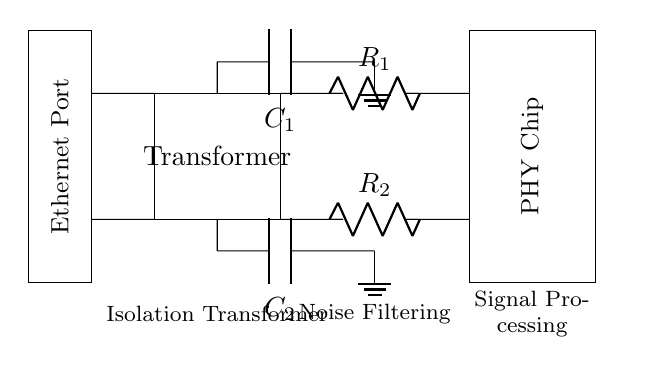What component is used for noise filtering? The circuit diagram shows capacitors C1 and C2 connected to the transformer for filtering noise. These capacitors are positioned after the secondary winding of the transformer, indicating their role in filtering unwanted frequencies from the signal.
Answer: Capacitors What is the primary function of the transformer? The transformer in this circuit is labeled as an isolation transformer. Its primary function is to provide electrical isolation between the network connection and the PHY chip, helping to prevent interference from noise and enhance signal integrity.
Answer: Isolation How many resistors are present in the circuit? The diagram clearly shows two resistors, R1 and R2, which are used for impedance matching. These resistors are connected to the secondary winding of the transformer before the signal reaches the PHY chip.
Answer: Two What is connected to the center taps of the transformer? The center taps of the transformer are connected to the noise-filtering capacitors C1 and C2. These connections allow for the capacitors to filter out noise from the signals being transmitted, ensuring that clean signals reach the PHY chip.
Answer: Capacitors What is the purpose of R1 and R2 in this circuit? R1 and R2 are identified as resistors for impedance matching in the circuit. Their purpose is to match the impedance of the transformer output to the input stage of the PHY chip, which helps in maximizing power transfer and minimizing reflections on the signal line.
Answer: Impedance matching What does the PHY chip do in the circuit? The PHY chip is responsible for signal processing in the circuit. It takes the filtered and isolated signals from the transformer and prepares them for transmission over the Ethernet connection, performing tasks such as encoding and decoding the data signals.
Answer: Signal processing 